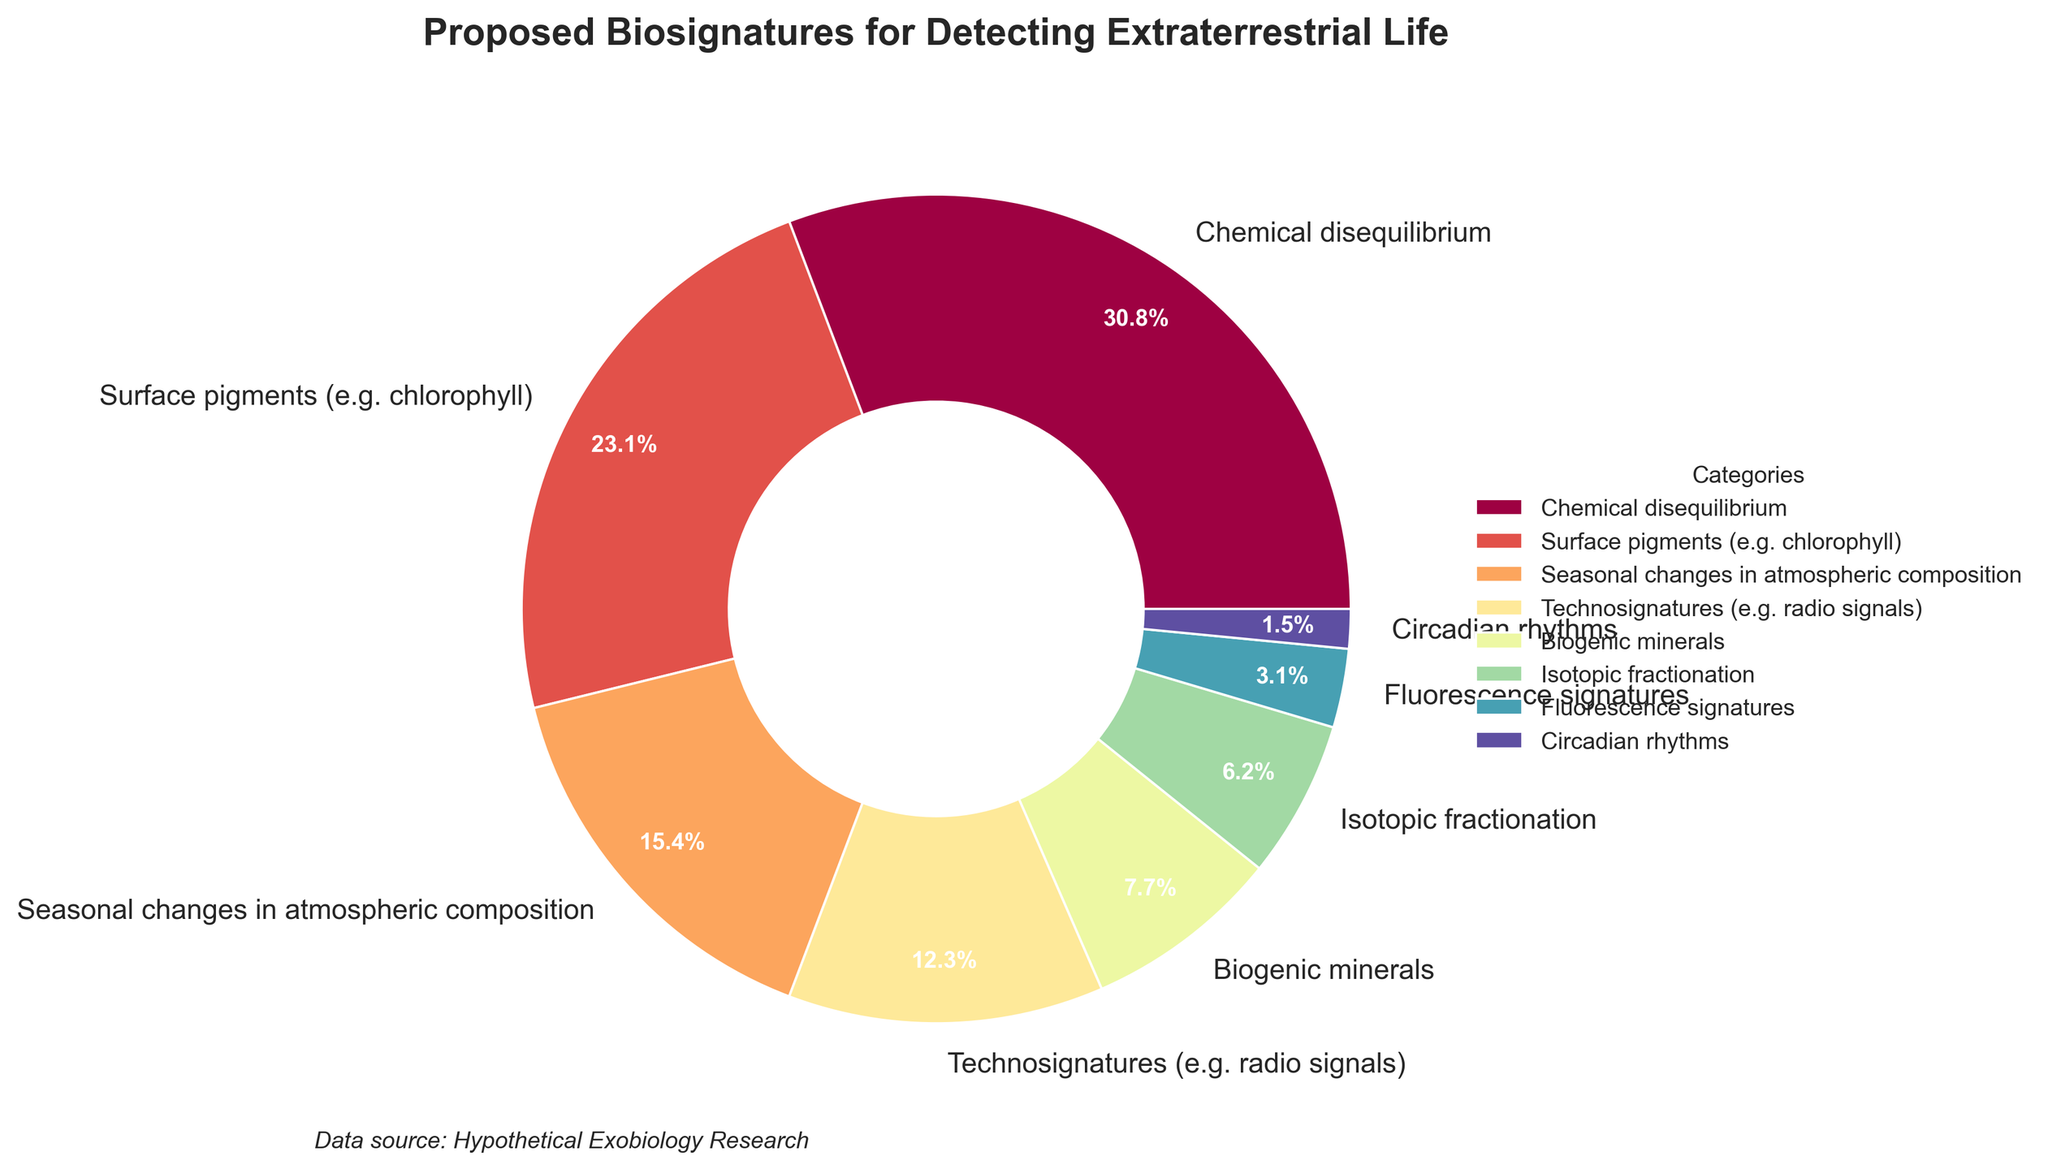Which biosignature has the largest percentage? To determine the biosignature with the largest percentage, identify the segment with the highest number. The largest percentage is 20% for "Chemical disequilibrium".
Answer: Chemical disequilibrium What is the combined percentage of Surface pigments and Technosignatures? Add the percentages of Surface pigments (15%) and Technosignatures (8%) together: 15% + 8% = 23%.
Answer: 23% How much greater is the percentage of Chemical disequilibrium compared to Fluorescence signatures? Subtract the percentage of Fluorescence signatures (2%) from the percentage of Chemical disequilibrium (20%): 20% - 2% = 18%.
Answer: 18% Which biosignature category is least represented? The biosignature category with the smallest percentage is the least represented. Circadian rhythms has the smallest percentage at 1%.
Answer: Circadian rhythms What is the total percentage of all the biosignatures related to atmospheric phenomena combined? Add the percentages of "Chemical disequilibrium" (20%) and "Seasonal changes in atmospheric composition" (10%): 20% + 10% = 30%.
Answer: 30% Are there more biosignature categories with percentages greater than 10% or less than 10%? Count the number of categories greater than 10% and those less than 10%. Greater than 10%: Chemical disequilibrium (20%), Surface pigments (15%) = 2 categories. Less than 10%: Seasonal changes (10%), Technosignatures (8%), Biogenic minerals (5%), Isotopic fractionation (4%), Fluorescence signatures (2%), Circadian rhythms (1%) = 6 categories.
Answer: Less than 10% What is the average percentage of the top three biosignature categories? Add the percentages of the top three categories: Chemical disequilibrium (20%), Surface pigments (15%), and Seasonal changes in atmospheric composition (10%). Sum = 45%. Then, divide by 3: 45% / 3 = 15%.
Answer: 15% Between Biogenic minerals and Isotopic fractionation, which has a higher percentage and by how much? Biogenic minerals has 5%, and Isotopic fractionation has 4%. Subtract the smaller percentage from the larger one: 5% - 4% = 1%.
Answer: Biogenic minerals by 1% What percentage of biosignature categories are represented by values below 5%? Count the biosignature categories below 5%: Isotopic fractionation (4%), Fluorescence signatures (2%), Circadian rhythms (1%). Sum up their individual percentages: 4% + 2% + 1% = 7%.
Answer: 7% 